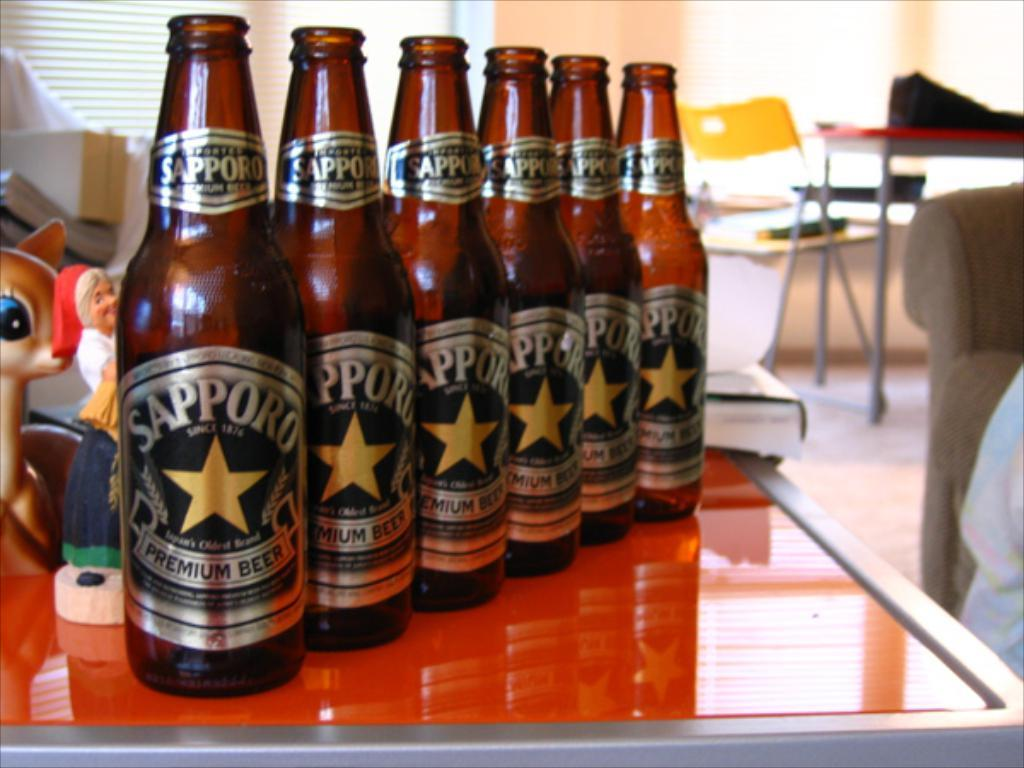<image>
Relay a brief, clear account of the picture shown. a line of beer bottles with each label reading sapporo premium beer 